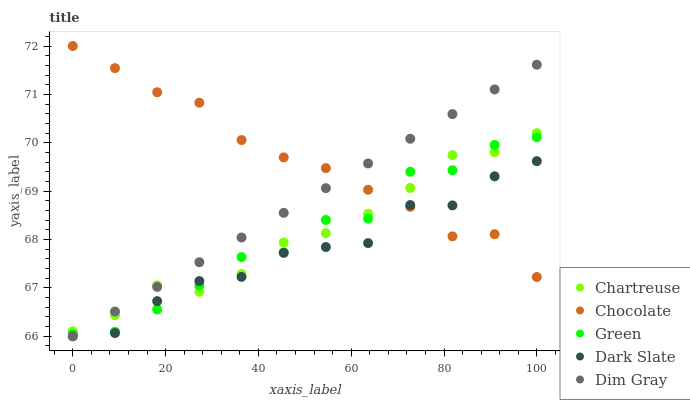Does Dark Slate have the minimum area under the curve?
Answer yes or no. Yes. Does Chocolate have the maximum area under the curve?
Answer yes or no. Yes. Does Chartreuse have the minimum area under the curve?
Answer yes or no. No. Does Chartreuse have the maximum area under the curve?
Answer yes or no. No. Is Dim Gray the smoothest?
Answer yes or no. Yes. Is Green the roughest?
Answer yes or no. Yes. Is Chartreuse the smoothest?
Answer yes or no. No. Is Chartreuse the roughest?
Answer yes or no. No. Does Dark Slate have the lowest value?
Answer yes or no. Yes. Does Chartreuse have the lowest value?
Answer yes or no. No. Does Chocolate have the highest value?
Answer yes or no. Yes. Does Chartreuse have the highest value?
Answer yes or no. No. Does Dark Slate intersect Chocolate?
Answer yes or no. Yes. Is Dark Slate less than Chocolate?
Answer yes or no. No. Is Dark Slate greater than Chocolate?
Answer yes or no. No. 